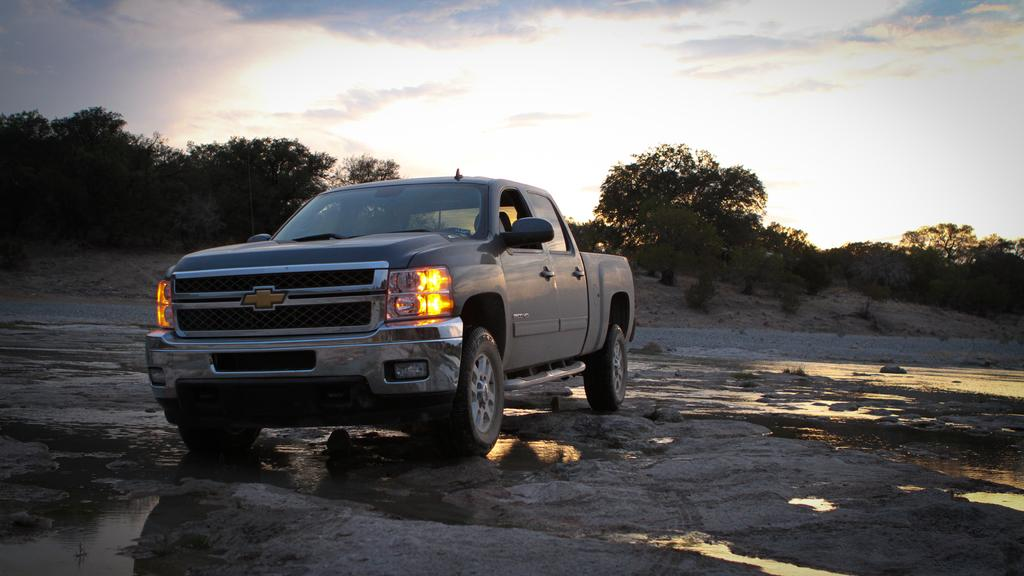What type of vehicle is in the image? There is a vehicle in the image, but the specific type is not mentioned. What feature can be seen on the front of the vehicle? The vehicle has headlights. What natural element is visible in the image? There is water visible in the image. What type of vegetation is present in the image? There are trees in the image. How would you describe the weather based on the image? The sky is cloudy in the image, suggesting a potentially overcast or cloudy day. Can you see a group of snakes slithering peacefully in the water in the image? There is no mention of snakes or any group of animals in the image; it primarily features a vehicle and its surroundings. 